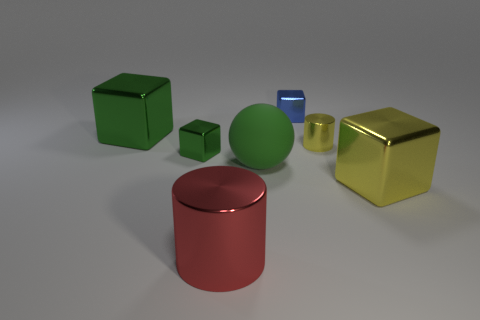Is there a large cube of the same color as the big rubber ball?
Make the answer very short. Yes. Do the yellow metallic cylinder and the matte thing have the same size?
Offer a very short reply. No. Is the color of the big matte ball the same as the small cylinder?
Keep it short and to the point. No. What is the green thing on the left side of the small cube that is on the left side of the large red metal cylinder made of?
Your answer should be very brief. Metal. There is another thing that is the same shape as the small yellow object; what is it made of?
Ensure brevity in your answer.  Metal. There is a green object that is to the right of the red metal object; is it the same size as the big cylinder?
Make the answer very short. Yes. What number of metal objects are gray cylinders or large objects?
Give a very brief answer. 3. There is a thing that is both in front of the large rubber sphere and left of the large matte ball; what is its material?
Your answer should be very brief. Metal. Is the big yellow object made of the same material as the tiny cylinder?
Offer a very short reply. Yes. There is a object that is both on the right side of the tiny blue block and in front of the small green metal object; what is its size?
Keep it short and to the point. Large. 